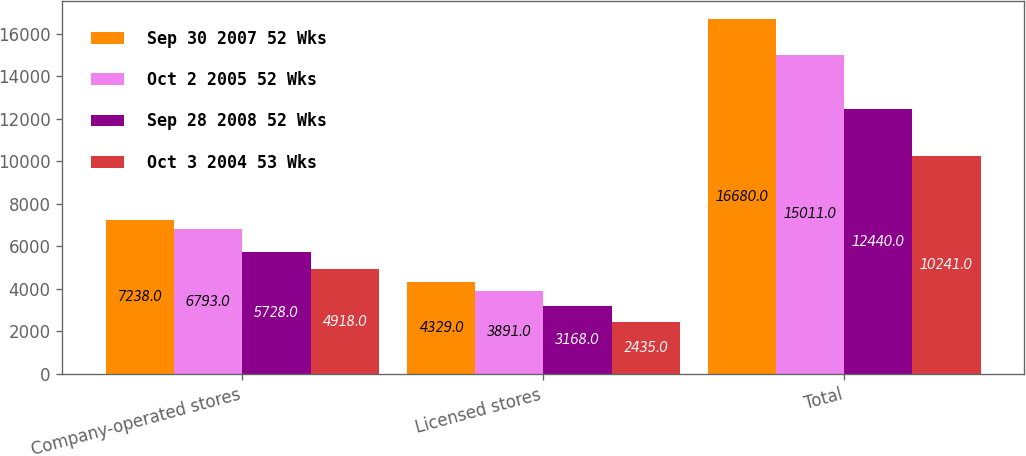<chart> <loc_0><loc_0><loc_500><loc_500><stacked_bar_chart><ecel><fcel>Company-operated stores<fcel>Licensed stores<fcel>Total<nl><fcel>Sep 30 2007 52 Wks<fcel>7238<fcel>4329<fcel>16680<nl><fcel>Oct 2 2005 52 Wks<fcel>6793<fcel>3891<fcel>15011<nl><fcel>Sep 28 2008 52 Wks<fcel>5728<fcel>3168<fcel>12440<nl><fcel>Oct 3 2004 53 Wks<fcel>4918<fcel>2435<fcel>10241<nl></chart> 